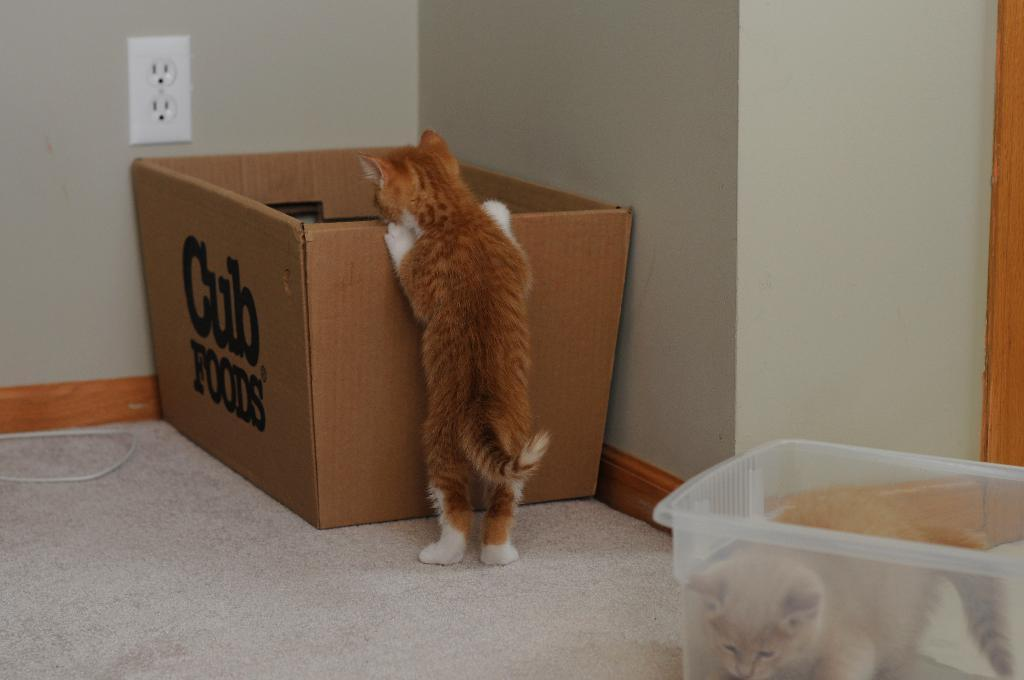<image>
Describe the image concisely. a cat looking into a box labeled 'cub foods' 